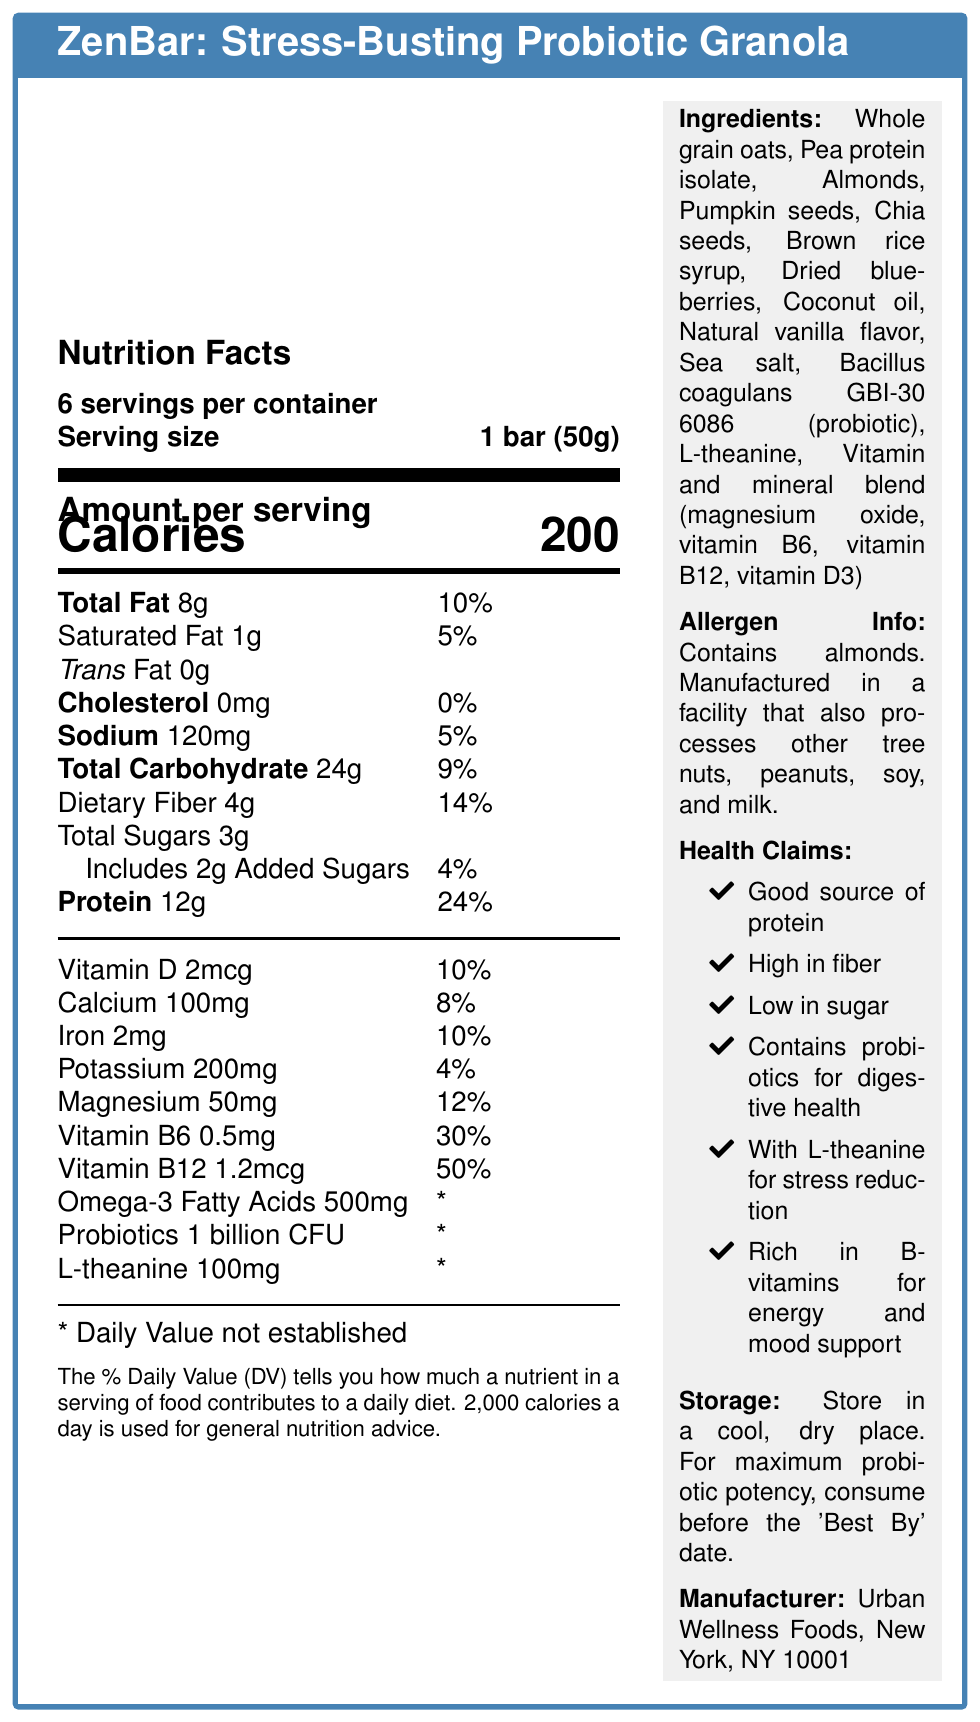what is the serving size of the ZenBar? The serving size is directly mentioned in the document under "Serving size."
Answer: 1 bar (50g) how many servings are there per container? The document states "6 servings per container."
Answer: 6 how many calories are in one serving? The document explicitly mentions that there are 200 calories per serving.
Answer: 200 how much protein does one ZenBar provide? The amount of protein per serving is listed as 12g.
Answer: 12g what percentage of the daily value of Vitamin B12 does one bar contain? It is listed in the document that one bar contains 50% of the daily value of Vitamin B12.
Answer: 50% which allergens are found in ZenBar? The allergen information indicates that the product contains almonds.
Answer: Almonds which ingredient is used as a probiotic in ZenBar? The ingredient list specifically mentions Bacillus coagulans GBI-30 6086 as the probiotic.
Answer: Bacillus coagulans GBI-30 6086 which nutrient is not provided with a daily value percentage? A. Omega-3 Fatty Acids B. Vitamin D C. Magnesium D. Iron The document shows that the daily value for Omega-3 Fatty Acids is marked with a "*", indicating it is not established.
Answer: A what is the daily value percentage for Sodium in one ZenBar? A. 0% B. 5% C. 10% D. 15% The sodium content is listed as 120mg, which constitutes 5% of the daily value.
Answer: B does ZenBar contain any trans fat? The nutrition facts label states that the trans fat amount is 0g.
Answer: No does this product need to be refrigerated? The storage instructions specify to store in a cool, dry place without mentioning refrigeration.
Answer: No summarize the main idea of this document. The document provides detailed nutritional information, ingredients, and health benefits of the ZenBar, emphasizing its high protein content, low sugar, and the inclusion of probiotics and mood-boosting nutrients.
Answer: ZenBar is a high-protein, low-sugar granola bar fortified with probiotics and mood-boosting nutrients like L-theanine. It provides various health benefits such as digestive health support, stress reduction, and is rich in B-vitamins for energy and mood support. what flavor is ZenBar? The document does not specify the flavor of the ZenBar.
Answer: Not enough information 